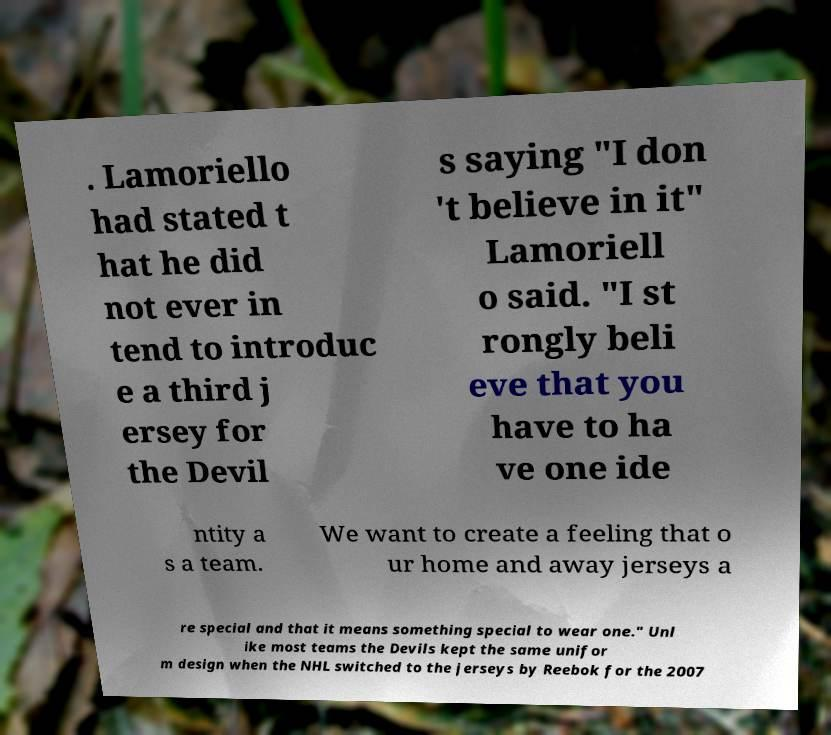I need the written content from this picture converted into text. Can you do that? . Lamoriello had stated t hat he did not ever in tend to introduc e a third j ersey for the Devil s saying "I don 't believe in it" Lamoriell o said. "I st rongly beli eve that you have to ha ve one ide ntity a s a team. We want to create a feeling that o ur home and away jerseys a re special and that it means something special to wear one." Unl ike most teams the Devils kept the same unifor m design when the NHL switched to the jerseys by Reebok for the 2007 